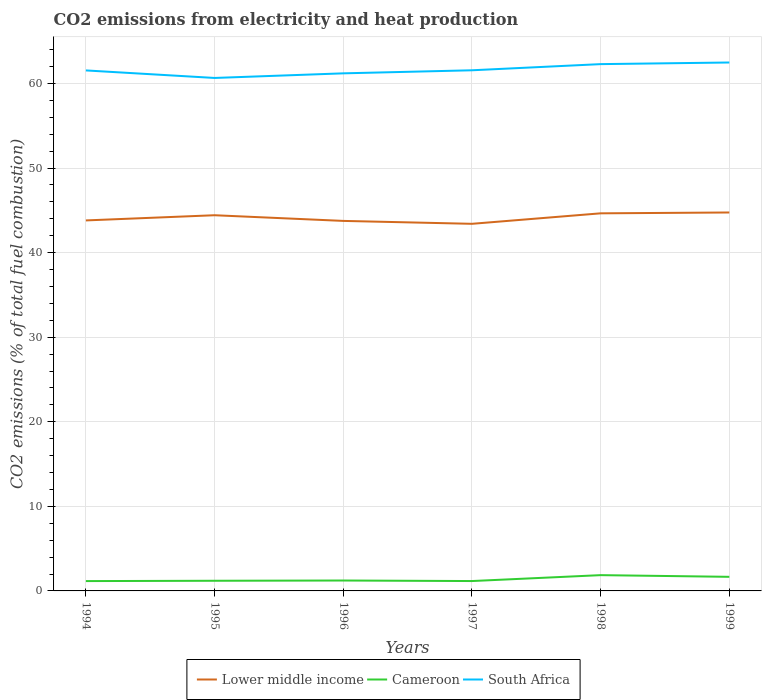How many different coloured lines are there?
Provide a succinct answer. 3. Across all years, what is the maximum amount of CO2 emitted in South Africa?
Offer a terse response. 60.65. In which year was the amount of CO2 emitted in South Africa maximum?
Your answer should be very brief. 1995. What is the total amount of CO2 emitted in South Africa in the graph?
Ensure brevity in your answer.  -0.54. What is the difference between the highest and the second highest amount of CO2 emitted in Lower middle income?
Provide a short and direct response. 1.34. What is the difference between the highest and the lowest amount of CO2 emitted in South Africa?
Give a very brief answer. 2. Is the amount of CO2 emitted in Lower middle income strictly greater than the amount of CO2 emitted in Cameroon over the years?
Ensure brevity in your answer.  No. What is the difference between two consecutive major ticks on the Y-axis?
Ensure brevity in your answer.  10. Are the values on the major ticks of Y-axis written in scientific E-notation?
Give a very brief answer. No. Does the graph contain any zero values?
Your response must be concise. No. How many legend labels are there?
Your answer should be compact. 3. What is the title of the graph?
Your answer should be compact. CO2 emissions from electricity and heat production. What is the label or title of the X-axis?
Your answer should be compact. Years. What is the label or title of the Y-axis?
Your response must be concise. CO2 emissions (% of total fuel combustion). What is the CO2 emissions (% of total fuel combustion) of Lower middle income in 1994?
Offer a very short reply. 43.8. What is the CO2 emissions (% of total fuel combustion) of Cameroon in 1994?
Provide a succinct answer. 1.16. What is the CO2 emissions (% of total fuel combustion) of South Africa in 1994?
Offer a terse response. 61.54. What is the CO2 emissions (% of total fuel combustion) of Lower middle income in 1995?
Offer a terse response. 44.42. What is the CO2 emissions (% of total fuel combustion) of Cameroon in 1995?
Provide a succinct answer. 1.2. What is the CO2 emissions (% of total fuel combustion) in South Africa in 1995?
Offer a very short reply. 60.65. What is the CO2 emissions (% of total fuel combustion) of Lower middle income in 1996?
Your answer should be compact. 43.74. What is the CO2 emissions (% of total fuel combustion) of Cameroon in 1996?
Your answer should be very brief. 1.23. What is the CO2 emissions (% of total fuel combustion) of South Africa in 1996?
Your response must be concise. 61.19. What is the CO2 emissions (% of total fuel combustion) of Lower middle income in 1997?
Make the answer very short. 43.4. What is the CO2 emissions (% of total fuel combustion) in Cameroon in 1997?
Provide a short and direct response. 1.17. What is the CO2 emissions (% of total fuel combustion) in South Africa in 1997?
Your response must be concise. 61.55. What is the CO2 emissions (% of total fuel combustion) of Lower middle income in 1998?
Ensure brevity in your answer.  44.64. What is the CO2 emissions (% of total fuel combustion) in Cameroon in 1998?
Make the answer very short. 1.87. What is the CO2 emissions (% of total fuel combustion) of South Africa in 1998?
Ensure brevity in your answer.  62.28. What is the CO2 emissions (% of total fuel combustion) of Lower middle income in 1999?
Offer a very short reply. 44.74. What is the CO2 emissions (% of total fuel combustion) in Cameroon in 1999?
Provide a short and direct response. 1.67. What is the CO2 emissions (% of total fuel combustion) in South Africa in 1999?
Your response must be concise. 62.47. Across all years, what is the maximum CO2 emissions (% of total fuel combustion) in Lower middle income?
Offer a terse response. 44.74. Across all years, what is the maximum CO2 emissions (% of total fuel combustion) in Cameroon?
Ensure brevity in your answer.  1.87. Across all years, what is the maximum CO2 emissions (% of total fuel combustion) in South Africa?
Give a very brief answer. 62.47. Across all years, what is the minimum CO2 emissions (% of total fuel combustion) in Lower middle income?
Provide a succinct answer. 43.4. Across all years, what is the minimum CO2 emissions (% of total fuel combustion) of Cameroon?
Provide a succinct answer. 1.16. Across all years, what is the minimum CO2 emissions (% of total fuel combustion) in South Africa?
Your response must be concise. 60.65. What is the total CO2 emissions (% of total fuel combustion) of Lower middle income in the graph?
Offer a very short reply. 264.75. What is the total CO2 emissions (% of total fuel combustion) in Cameroon in the graph?
Keep it short and to the point. 8.29. What is the total CO2 emissions (% of total fuel combustion) of South Africa in the graph?
Your answer should be compact. 369.68. What is the difference between the CO2 emissions (% of total fuel combustion) of Lower middle income in 1994 and that in 1995?
Ensure brevity in your answer.  -0.61. What is the difference between the CO2 emissions (% of total fuel combustion) in Cameroon in 1994 and that in 1995?
Offer a terse response. -0.04. What is the difference between the CO2 emissions (% of total fuel combustion) of South Africa in 1994 and that in 1995?
Your answer should be very brief. 0.89. What is the difference between the CO2 emissions (% of total fuel combustion) in Lower middle income in 1994 and that in 1996?
Provide a short and direct response. 0.06. What is the difference between the CO2 emissions (% of total fuel combustion) of Cameroon in 1994 and that in 1996?
Provide a short and direct response. -0.07. What is the difference between the CO2 emissions (% of total fuel combustion) of South Africa in 1994 and that in 1996?
Your answer should be very brief. 0.35. What is the difference between the CO2 emissions (% of total fuel combustion) in Lower middle income in 1994 and that in 1997?
Offer a terse response. 0.4. What is the difference between the CO2 emissions (% of total fuel combustion) of Cameroon in 1994 and that in 1997?
Your answer should be compact. -0. What is the difference between the CO2 emissions (% of total fuel combustion) of South Africa in 1994 and that in 1997?
Your answer should be very brief. -0.02. What is the difference between the CO2 emissions (% of total fuel combustion) in Lower middle income in 1994 and that in 1998?
Give a very brief answer. -0.84. What is the difference between the CO2 emissions (% of total fuel combustion) in Cameroon in 1994 and that in 1998?
Make the answer very short. -0.7. What is the difference between the CO2 emissions (% of total fuel combustion) in South Africa in 1994 and that in 1998?
Provide a short and direct response. -0.74. What is the difference between the CO2 emissions (% of total fuel combustion) in Lower middle income in 1994 and that in 1999?
Offer a very short reply. -0.94. What is the difference between the CO2 emissions (% of total fuel combustion) in Cameroon in 1994 and that in 1999?
Provide a succinct answer. -0.5. What is the difference between the CO2 emissions (% of total fuel combustion) of South Africa in 1994 and that in 1999?
Your response must be concise. -0.94. What is the difference between the CO2 emissions (% of total fuel combustion) of Lower middle income in 1995 and that in 1996?
Provide a succinct answer. 0.67. What is the difference between the CO2 emissions (% of total fuel combustion) in Cameroon in 1995 and that in 1996?
Give a very brief answer. -0.03. What is the difference between the CO2 emissions (% of total fuel combustion) of South Africa in 1995 and that in 1996?
Provide a succinct answer. -0.54. What is the difference between the CO2 emissions (% of total fuel combustion) of Lower middle income in 1995 and that in 1997?
Provide a succinct answer. 1.01. What is the difference between the CO2 emissions (% of total fuel combustion) of Cameroon in 1995 and that in 1997?
Your answer should be compact. 0.03. What is the difference between the CO2 emissions (% of total fuel combustion) in South Africa in 1995 and that in 1997?
Ensure brevity in your answer.  -0.91. What is the difference between the CO2 emissions (% of total fuel combustion) of Lower middle income in 1995 and that in 1998?
Your response must be concise. -0.23. What is the difference between the CO2 emissions (% of total fuel combustion) of Cameroon in 1995 and that in 1998?
Provide a short and direct response. -0.67. What is the difference between the CO2 emissions (% of total fuel combustion) of South Africa in 1995 and that in 1998?
Make the answer very short. -1.63. What is the difference between the CO2 emissions (% of total fuel combustion) in Lower middle income in 1995 and that in 1999?
Provide a succinct answer. -0.32. What is the difference between the CO2 emissions (% of total fuel combustion) in Cameroon in 1995 and that in 1999?
Offer a very short reply. -0.47. What is the difference between the CO2 emissions (% of total fuel combustion) of South Africa in 1995 and that in 1999?
Your response must be concise. -1.83. What is the difference between the CO2 emissions (% of total fuel combustion) in Lower middle income in 1996 and that in 1997?
Keep it short and to the point. 0.34. What is the difference between the CO2 emissions (% of total fuel combustion) of Cameroon in 1996 and that in 1997?
Give a very brief answer. 0.06. What is the difference between the CO2 emissions (% of total fuel combustion) of South Africa in 1996 and that in 1997?
Offer a very short reply. -0.36. What is the difference between the CO2 emissions (% of total fuel combustion) of Lower middle income in 1996 and that in 1998?
Your answer should be compact. -0.9. What is the difference between the CO2 emissions (% of total fuel combustion) in Cameroon in 1996 and that in 1998?
Give a very brief answer. -0.64. What is the difference between the CO2 emissions (% of total fuel combustion) in South Africa in 1996 and that in 1998?
Your answer should be compact. -1.09. What is the difference between the CO2 emissions (% of total fuel combustion) in Lower middle income in 1996 and that in 1999?
Offer a very short reply. -1. What is the difference between the CO2 emissions (% of total fuel combustion) of Cameroon in 1996 and that in 1999?
Your answer should be compact. -0.44. What is the difference between the CO2 emissions (% of total fuel combustion) of South Africa in 1996 and that in 1999?
Provide a succinct answer. -1.28. What is the difference between the CO2 emissions (% of total fuel combustion) of Lower middle income in 1997 and that in 1998?
Your answer should be compact. -1.24. What is the difference between the CO2 emissions (% of total fuel combustion) in Cameroon in 1997 and that in 1998?
Keep it short and to the point. -0.7. What is the difference between the CO2 emissions (% of total fuel combustion) in South Africa in 1997 and that in 1998?
Provide a short and direct response. -0.73. What is the difference between the CO2 emissions (% of total fuel combustion) in Lower middle income in 1997 and that in 1999?
Provide a succinct answer. -1.34. What is the difference between the CO2 emissions (% of total fuel combustion) in Cameroon in 1997 and that in 1999?
Offer a very short reply. -0.5. What is the difference between the CO2 emissions (% of total fuel combustion) of South Africa in 1997 and that in 1999?
Your answer should be very brief. -0.92. What is the difference between the CO2 emissions (% of total fuel combustion) in Lower middle income in 1998 and that in 1999?
Ensure brevity in your answer.  -0.1. What is the difference between the CO2 emissions (% of total fuel combustion) of Cameroon in 1998 and that in 1999?
Offer a very short reply. 0.2. What is the difference between the CO2 emissions (% of total fuel combustion) in South Africa in 1998 and that in 1999?
Keep it short and to the point. -0.19. What is the difference between the CO2 emissions (% of total fuel combustion) in Lower middle income in 1994 and the CO2 emissions (% of total fuel combustion) in Cameroon in 1995?
Offer a terse response. 42.6. What is the difference between the CO2 emissions (% of total fuel combustion) of Lower middle income in 1994 and the CO2 emissions (% of total fuel combustion) of South Africa in 1995?
Your answer should be very brief. -16.84. What is the difference between the CO2 emissions (% of total fuel combustion) of Cameroon in 1994 and the CO2 emissions (% of total fuel combustion) of South Africa in 1995?
Offer a very short reply. -59.48. What is the difference between the CO2 emissions (% of total fuel combustion) in Lower middle income in 1994 and the CO2 emissions (% of total fuel combustion) in Cameroon in 1996?
Your answer should be very brief. 42.57. What is the difference between the CO2 emissions (% of total fuel combustion) in Lower middle income in 1994 and the CO2 emissions (% of total fuel combustion) in South Africa in 1996?
Offer a very short reply. -17.39. What is the difference between the CO2 emissions (% of total fuel combustion) of Cameroon in 1994 and the CO2 emissions (% of total fuel combustion) of South Africa in 1996?
Give a very brief answer. -60.03. What is the difference between the CO2 emissions (% of total fuel combustion) of Lower middle income in 1994 and the CO2 emissions (% of total fuel combustion) of Cameroon in 1997?
Provide a succinct answer. 42.63. What is the difference between the CO2 emissions (% of total fuel combustion) of Lower middle income in 1994 and the CO2 emissions (% of total fuel combustion) of South Africa in 1997?
Give a very brief answer. -17.75. What is the difference between the CO2 emissions (% of total fuel combustion) in Cameroon in 1994 and the CO2 emissions (% of total fuel combustion) in South Africa in 1997?
Provide a short and direct response. -60.39. What is the difference between the CO2 emissions (% of total fuel combustion) of Lower middle income in 1994 and the CO2 emissions (% of total fuel combustion) of Cameroon in 1998?
Provide a short and direct response. 41.94. What is the difference between the CO2 emissions (% of total fuel combustion) of Lower middle income in 1994 and the CO2 emissions (% of total fuel combustion) of South Africa in 1998?
Provide a short and direct response. -18.48. What is the difference between the CO2 emissions (% of total fuel combustion) of Cameroon in 1994 and the CO2 emissions (% of total fuel combustion) of South Africa in 1998?
Offer a very short reply. -61.12. What is the difference between the CO2 emissions (% of total fuel combustion) of Lower middle income in 1994 and the CO2 emissions (% of total fuel combustion) of Cameroon in 1999?
Offer a terse response. 42.14. What is the difference between the CO2 emissions (% of total fuel combustion) of Lower middle income in 1994 and the CO2 emissions (% of total fuel combustion) of South Africa in 1999?
Offer a very short reply. -18.67. What is the difference between the CO2 emissions (% of total fuel combustion) of Cameroon in 1994 and the CO2 emissions (% of total fuel combustion) of South Africa in 1999?
Offer a very short reply. -61.31. What is the difference between the CO2 emissions (% of total fuel combustion) in Lower middle income in 1995 and the CO2 emissions (% of total fuel combustion) in Cameroon in 1996?
Ensure brevity in your answer.  43.19. What is the difference between the CO2 emissions (% of total fuel combustion) of Lower middle income in 1995 and the CO2 emissions (% of total fuel combustion) of South Africa in 1996?
Your response must be concise. -16.78. What is the difference between the CO2 emissions (% of total fuel combustion) in Cameroon in 1995 and the CO2 emissions (% of total fuel combustion) in South Africa in 1996?
Provide a succinct answer. -59.99. What is the difference between the CO2 emissions (% of total fuel combustion) in Lower middle income in 1995 and the CO2 emissions (% of total fuel combustion) in Cameroon in 1997?
Your response must be concise. 43.25. What is the difference between the CO2 emissions (% of total fuel combustion) of Lower middle income in 1995 and the CO2 emissions (% of total fuel combustion) of South Africa in 1997?
Offer a terse response. -17.14. What is the difference between the CO2 emissions (% of total fuel combustion) in Cameroon in 1995 and the CO2 emissions (% of total fuel combustion) in South Africa in 1997?
Keep it short and to the point. -60.35. What is the difference between the CO2 emissions (% of total fuel combustion) of Lower middle income in 1995 and the CO2 emissions (% of total fuel combustion) of Cameroon in 1998?
Ensure brevity in your answer.  42.55. What is the difference between the CO2 emissions (% of total fuel combustion) of Lower middle income in 1995 and the CO2 emissions (% of total fuel combustion) of South Africa in 1998?
Your answer should be compact. -17.87. What is the difference between the CO2 emissions (% of total fuel combustion) in Cameroon in 1995 and the CO2 emissions (% of total fuel combustion) in South Africa in 1998?
Offer a terse response. -61.08. What is the difference between the CO2 emissions (% of total fuel combustion) of Lower middle income in 1995 and the CO2 emissions (% of total fuel combustion) of Cameroon in 1999?
Provide a succinct answer. 42.75. What is the difference between the CO2 emissions (% of total fuel combustion) of Lower middle income in 1995 and the CO2 emissions (% of total fuel combustion) of South Africa in 1999?
Make the answer very short. -18.06. What is the difference between the CO2 emissions (% of total fuel combustion) of Cameroon in 1995 and the CO2 emissions (% of total fuel combustion) of South Africa in 1999?
Your answer should be compact. -61.27. What is the difference between the CO2 emissions (% of total fuel combustion) in Lower middle income in 1996 and the CO2 emissions (% of total fuel combustion) in Cameroon in 1997?
Your response must be concise. 42.58. What is the difference between the CO2 emissions (% of total fuel combustion) of Lower middle income in 1996 and the CO2 emissions (% of total fuel combustion) of South Africa in 1997?
Give a very brief answer. -17.81. What is the difference between the CO2 emissions (% of total fuel combustion) in Cameroon in 1996 and the CO2 emissions (% of total fuel combustion) in South Africa in 1997?
Offer a very short reply. -60.32. What is the difference between the CO2 emissions (% of total fuel combustion) in Lower middle income in 1996 and the CO2 emissions (% of total fuel combustion) in Cameroon in 1998?
Make the answer very short. 41.88. What is the difference between the CO2 emissions (% of total fuel combustion) of Lower middle income in 1996 and the CO2 emissions (% of total fuel combustion) of South Africa in 1998?
Offer a very short reply. -18.54. What is the difference between the CO2 emissions (% of total fuel combustion) of Cameroon in 1996 and the CO2 emissions (% of total fuel combustion) of South Africa in 1998?
Your answer should be compact. -61.05. What is the difference between the CO2 emissions (% of total fuel combustion) in Lower middle income in 1996 and the CO2 emissions (% of total fuel combustion) in Cameroon in 1999?
Your answer should be very brief. 42.08. What is the difference between the CO2 emissions (% of total fuel combustion) in Lower middle income in 1996 and the CO2 emissions (% of total fuel combustion) in South Africa in 1999?
Ensure brevity in your answer.  -18.73. What is the difference between the CO2 emissions (% of total fuel combustion) in Cameroon in 1996 and the CO2 emissions (% of total fuel combustion) in South Africa in 1999?
Provide a succinct answer. -61.24. What is the difference between the CO2 emissions (% of total fuel combustion) of Lower middle income in 1997 and the CO2 emissions (% of total fuel combustion) of Cameroon in 1998?
Your answer should be very brief. 41.54. What is the difference between the CO2 emissions (% of total fuel combustion) of Lower middle income in 1997 and the CO2 emissions (% of total fuel combustion) of South Africa in 1998?
Make the answer very short. -18.88. What is the difference between the CO2 emissions (% of total fuel combustion) of Cameroon in 1997 and the CO2 emissions (% of total fuel combustion) of South Africa in 1998?
Keep it short and to the point. -61.11. What is the difference between the CO2 emissions (% of total fuel combustion) in Lower middle income in 1997 and the CO2 emissions (% of total fuel combustion) in Cameroon in 1999?
Give a very brief answer. 41.74. What is the difference between the CO2 emissions (% of total fuel combustion) in Lower middle income in 1997 and the CO2 emissions (% of total fuel combustion) in South Africa in 1999?
Ensure brevity in your answer.  -19.07. What is the difference between the CO2 emissions (% of total fuel combustion) in Cameroon in 1997 and the CO2 emissions (% of total fuel combustion) in South Africa in 1999?
Keep it short and to the point. -61.31. What is the difference between the CO2 emissions (% of total fuel combustion) in Lower middle income in 1998 and the CO2 emissions (% of total fuel combustion) in Cameroon in 1999?
Your answer should be very brief. 42.98. What is the difference between the CO2 emissions (% of total fuel combustion) in Lower middle income in 1998 and the CO2 emissions (% of total fuel combustion) in South Africa in 1999?
Provide a short and direct response. -17.83. What is the difference between the CO2 emissions (% of total fuel combustion) in Cameroon in 1998 and the CO2 emissions (% of total fuel combustion) in South Africa in 1999?
Your response must be concise. -60.61. What is the average CO2 emissions (% of total fuel combustion) of Lower middle income per year?
Offer a very short reply. 44.12. What is the average CO2 emissions (% of total fuel combustion) in Cameroon per year?
Keep it short and to the point. 1.38. What is the average CO2 emissions (% of total fuel combustion) in South Africa per year?
Keep it short and to the point. 61.61. In the year 1994, what is the difference between the CO2 emissions (% of total fuel combustion) in Lower middle income and CO2 emissions (% of total fuel combustion) in Cameroon?
Your response must be concise. 42.64. In the year 1994, what is the difference between the CO2 emissions (% of total fuel combustion) in Lower middle income and CO2 emissions (% of total fuel combustion) in South Africa?
Ensure brevity in your answer.  -17.74. In the year 1994, what is the difference between the CO2 emissions (% of total fuel combustion) of Cameroon and CO2 emissions (% of total fuel combustion) of South Africa?
Offer a very short reply. -60.37. In the year 1995, what is the difference between the CO2 emissions (% of total fuel combustion) in Lower middle income and CO2 emissions (% of total fuel combustion) in Cameroon?
Give a very brief answer. 43.22. In the year 1995, what is the difference between the CO2 emissions (% of total fuel combustion) in Lower middle income and CO2 emissions (% of total fuel combustion) in South Africa?
Ensure brevity in your answer.  -16.23. In the year 1995, what is the difference between the CO2 emissions (% of total fuel combustion) in Cameroon and CO2 emissions (% of total fuel combustion) in South Africa?
Your answer should be very brief. -59.45. In the year 1996, what is the difference between the CO2 emissions (% of total fuel combustion) in Lower middle income and CO2 emissions (% of total fuel combustion) in Cameroon?
Provide a short and direct response. 42.52. In the year 1996, what is the difference between the CO2 emissions (% of total fuel combustion) of Lower middle income and CO2 emissions (% of total fuel combustion) of South Africa?
Provide a succinct answer. -17.45. In the year 1996, what is the difference between the CO2 emissions (% of total fuel combustion) of Cameroon and CO2 emissions (% of total fuel combustion) of South Africa?
Offer a terse response. -59.96. In the year 1997, what is the difference between the CO2 emissions (% of total fuel combustion) of Lower middle income and CO2 emissions (% of total fuel combustion) of Cameroon?
Your response must be concise. 42.23. In the year 1997, what is the difference between the CO2 emissions (% of total fuel combustion) in Lower middle income and CO2 emissions (% of total fuel combustion) in South Africa?
Make the answer very short. -18.15. In the year 1997, what is the difference between the CO2 emissions (% of total fuel combustion) in Cameroon and CO2 emissions (% of total fuel combustion) in South Africa?
Your response must be concise. -60.39. In the year 1998, what is the difference between the CO2 emissions (% of total fuel combustion) of Lower middle income and CO2 emissions (% of total fuel combustion) of Cameroon?
Offer a terse response. 42.78. In the year 1998, what is the difference between the CO2 emissions (% of total fuel combustion) in Lower middle income and CO2 emissions (% of total fuel combustion) in South Africa?
Offer a very short reply. -17.64. In the year 1998, what is the difference between the CO2 emissions (% of total fuel combustion) in Cameroon and CO2 emissions (% of total fuel combustion) in South Africa?
Provide a succinct answer. -60.42. In the year 1999, what is the difference between the CO2 emissions (% of total fuel combustion) in Lower middle income and CO2 emissions (% of total fuel combustion) in Cameroon?
Keep it short and to the point. 43.07. In the year 1999, what is the difference between the CO2 emissions (% of total fuel combustion) in Lower middle income and CO2 emissions (% of total fuel combustion) in South Africa?
Provide a succinct answer. -17.73. In the year 1999, what is the difference between the CO2 emissions (% of total fuel combustion) in Cameroon and CO2 emissions (% of total fuel combustion) in South Africa?
Make the answer very short. -60.81. What is the ratio of the CO2 emissions (% of total fuel combustion) in Lower middle income in 1994 to that in 1995?
Your response must be concise. 0.99. What is the ratio of the CO2 emissions (% of total fuel combustion) of South Africa in 1994 to that in 1995?
Give a very brief answer. 1.01. What is the ratio of the CO2 emissions (% of total fuel combustion) in Cameroon in 1994 to that in 1996?
Your answer should be compact. 0.95. What is the ratio of the CO2 emissions (% of total fuel combustion) of South Africa in 1994 to that in 1996?
Your answer should be compact. 1.01. What is the ratio of the CO2 emissions (% of total fuel combustion) of Lower middle income in 1994 to that in 1997?
Ensure brevity in your answer.  1.01. What is the ratio of the CO2 emissions (% of total fuel combustion) in Lower middle income in 1994 to that in 1998?
Provide a short and direct response. 0.98. What is the ratio of the CO2 emissions (% of total fuel combustion) of Cameroon in 1994 to that in 1998?
Provide a short and direct response. 0.62. What is the ratio of the CO2 emissions (% of total fuel combustion) of Cameroon in 1994 to that in 1999?
Make the answer very short. 0.7. What is the ratio of the CO2 emissions (% of total fuel combustion) in Lower middle income in 1995 to that in 1996?
Keep it short and to the point. 1.02. What is the ratio of the CO2 emissions (% of total fuel combustion) of South Africa in 1995 to that in 1996?
Ensure brevity in your answer.  0.99. What is the ratio of the CO2 emissions (% of total fuel combustion) in Lower middle income in 1995 to that in 1997?
Your response must be concise. 1.02. What is the ratio of the CO2 emissions (% of total fuel combustion) of Cameroon in 1995 to that in 1997?
Provide a succinct answer. 1.03. What is the ratio of the CO2 emissions (% of total fuel combustion) of Cameroon in 1995 to that in 1998?
Provide a succinct answer. 0.64. What is the ratio of the CO2 emissions (% of total fuel combustion) in South Africa in 1995 to that in 1998?
Keep it short and to the point. 0.97. What is the ratio of the CO2 emissions (% of total fuel combustion) in Lower middle income in 1995 to that in 1999?
Your answer should be compact. 0.99. What is the ratio of the CO2 emissions (% of total fuel combustion) in Cameroon in 1995 to that in 1999?
Provide a short and direct response. 0.72. What is the ratio of the CO2 emissions (% of total fuel combustion) in South Africa in 1995 to that in 1999?
Your answer should be very brief. 0.97. What is the ratio of the CO2 emissions (% of total fuel combustion) of Lower middle income in 1996 to that in 1997?
Offer a very short reply. 1.01. What is the ratio of the CO2 emissions (% of total fuel combustion) of Cameroon in 1996 to that in 1997?
Make the answer very short. 1.05. What is the ratio of the CO2 emissions (% of total fuel combustion) in South Africa in 1996 to that in 1997?
Your response must be concise. 0.99. What is the ratio of the CO2 emissions (% of total fuel combustion) of Lower middle income in 1996 to that in 1998?
Your answer should be very brief. 0.98. What is the ratio of the CO2 emissions (% of total fuel combustion) of Cameroon in 1996 to that in 1998?
Your response must be concise. 0.66. What is the ratio of the CO2 emissions (% of total fuel combustion) in South Africa in 1996 to that in 1998?
Provide a succinct answer. 0.98. What is the ratio of the CO2 emissions (% of total fuel combustion) in Lower middle income in 1996 to that in 1999?
Offer a terse response. 0.98. What is the ratio of the CO2 emissions (% of total fuel combustion) of Cameroon in 1996 to that in 1999?
Make the answer very short. 0.74. What is the ratio of the CO2 emissions (% of total fuel combustion) of South Africa in 1996 to that in 1999?
Ensure brevity in your answer.  0.98. What is the ratio of the CO2 emissions (% of total fuel combustion) of Lower middle income in 1997 to that in 1998?
Keep it short and to the point. 0.97. What is the ratio of the CO2 emissions (% of total fuel combustion) in Cameroon in 1997 to that in 1998?
Ensure brevity in your answer.  0.63. What is the ratio of the CO2 emissions (% of total fuel combustion) in South Africa in 1997 to that in 1998?
Make the answer very short. 0.99. What is the ratio of the CO2 emissions (% of total fuel combustion) of Lower middle income in 1997 to that in 1999?
Make the answer very short. 0.97. What is the ratio of the CO2 emissions (% of total fuel combustion) of Cameroon in 1997 to that in 1999?
Your response must be concise. 0.7. What is the ratio of the CO2 emissions (% of total fuel combustion) of Cameroon in 1998 to that in 1999?
Offer a terse response. 1.12. What is the ratio of the CO2 emissions (% of total fuel combustion) of South Africa in 1998 to that in 1999?
Provide a succinct answer. 1. What is the difference between the highest and the second highest CO2 emissions (% of total fuel combustion) of Lower middle income?
Your response must be concise. 0.1. What is the difference between the highest and the second highest CO2 emissions (% of total fuel combustion) of Cameroon?
Offer a terse response. 0.2. What is the difference between the highest and the second highest CO2 emissions (% of total fuel combustion) of South Africa?
Keep it short and to the point. 0.19. What is the difference between the highest and the lowest CO2 emissions (% of total fuel combustion) of Lower middle income?
Provide a short and direct response. 1.34. What is the difference between the highest and the lowest CO2 emissions (% of total fuel combustion) of Cameroon?
Your answer should be very brief. 0.7. What is the difference between the highest and the lowest CO2 emissions (% of total fuel combustion) of South Africa?
Ensure brevity in your answer.  1.83. 